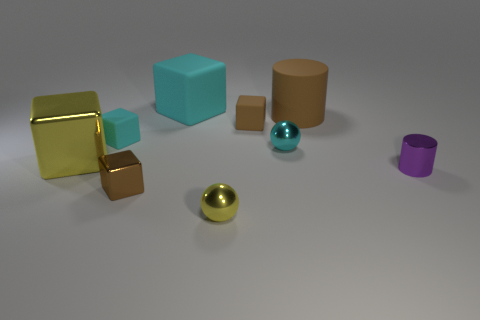Subtract all large matte blocks. How many blocks are left? 4 Subtract all cyan cubes. How many cubes are left? 3 Add 1 large yellow things. How many objects exist? 10 Subtract 1 cylinders. How many cylinders are left? 1 Add 7 brown objects. How many brown objects are left? 10 Add 2 yellow things. How many yellow things exist? 4 Subtract 1 brown cylinders. How many objects are left? 8 Subtract all cylinders. How many objects are left? 7 Subtract all cyan balls. Subtract all red cylinders. How many balls are left? 1 Subtract all gray spheres. How many blue blocks are left? 0 